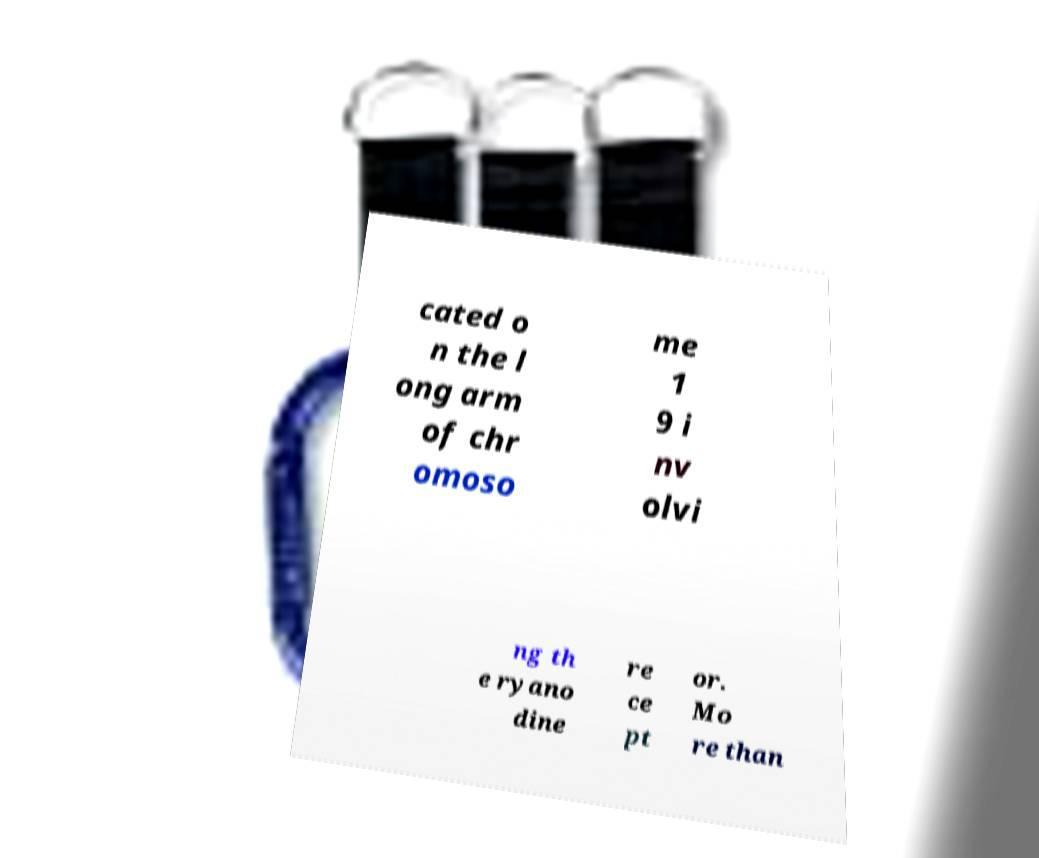What messages or text are displayed in this image? I need them in a readable, typed format. cated o n the l ong arm of chr omoso me 1 9 i nv olvi ng th e ryano dine re ce pt or. Mo re than 